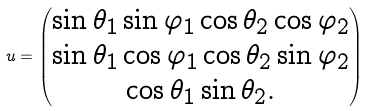<formula> <loc_0><loc_0><loc_500><loc_500>u = \begin{pmatrix} \sin \theta _ { 1 } \sin \varphi _ { 1 } \cos \theta _ { 2 } \cos \varphi _ { 2 } \\ \sin \theta _ { 1 } \cos \varphi _ { 1 } \cos \theta _ { 2 } \sin \varphi _ { 2 } \\ \cos \theta _ { 1 } \sin \theta _ { 2 } . \end{pmatrix}</formula> 